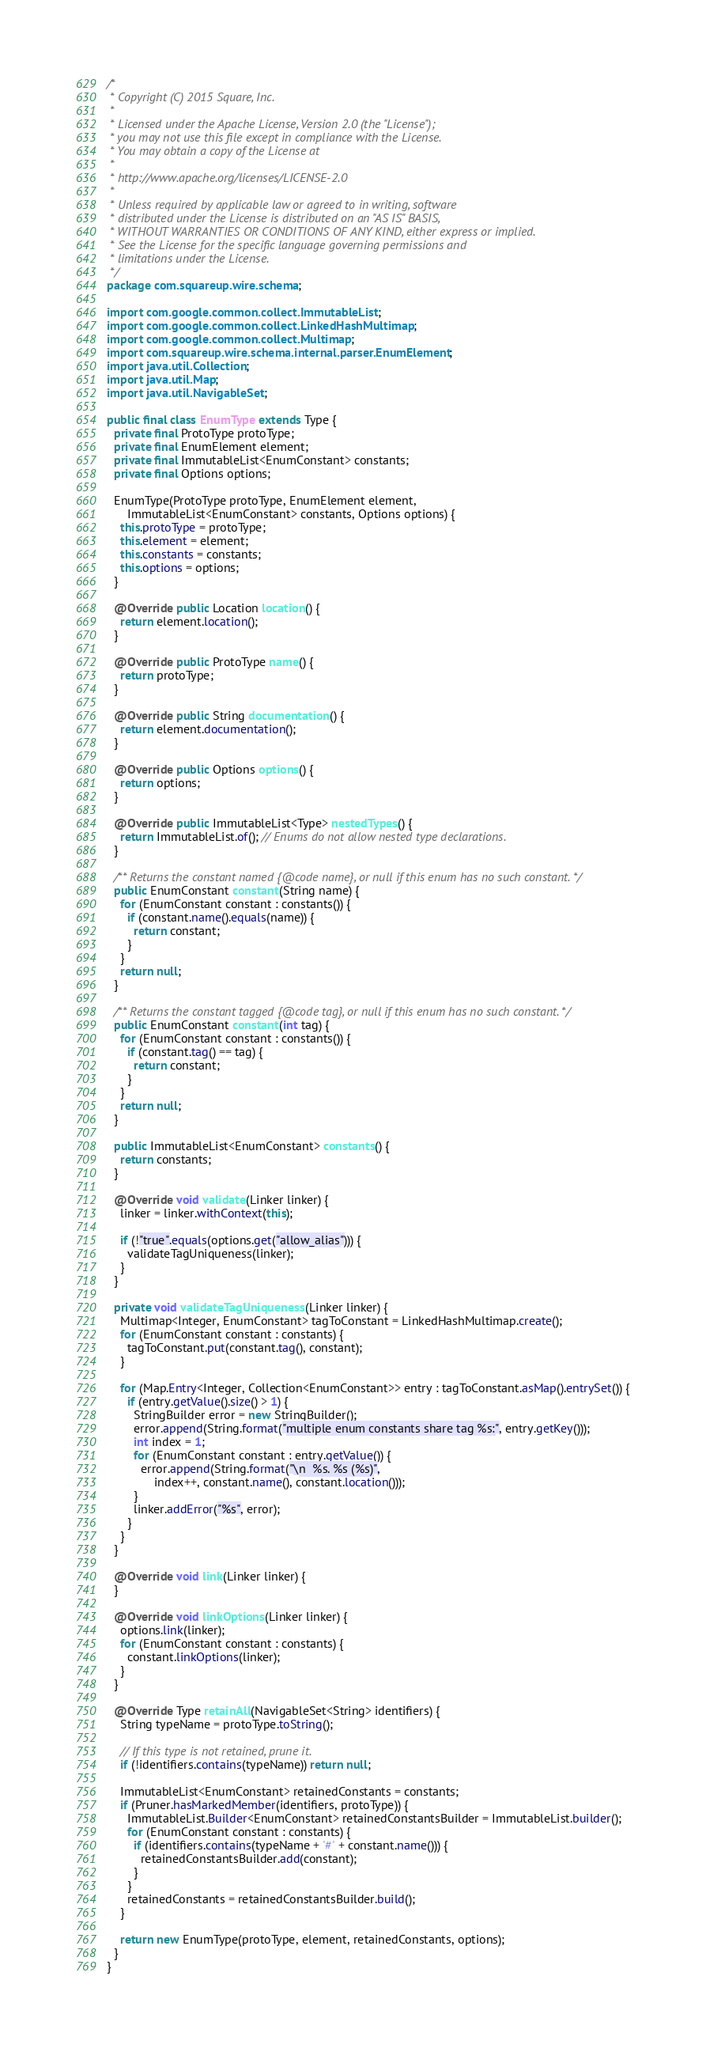<code> <loc_0><loc_0><loc_500><loc_500><_Java_>/*
 * Copyright (C) 2015 Square, Inc.
 *
 * Licensed under the Apache License, Version 2.0 (the "License");
 * you may not use this file except in compliance with the License.
 * You may obtain a copy of the License at
 *
 * http://www.apache.org/licenses/LICENSE-2.0
 *
 * Unless required by applicable law or agreed to in writing, software
 * distributed under the License is distributed on an "AS IS" BASIS,
 * WITHOUT WARRANTIES OR CONDITIONS OF ANY KIND, either express or implied.
 * See the License for the specific language governing permissions and
 * limitations under the License.
 */
package com.squareup.wire.schema;

import com.google.common.collect.ImmutableList;
import com.google.common.collect.LinkedHashMultimap;
import com.google.common.collect.Multimap;
import com.squareup.wire.schema.internal.parser.EnumElement;
import java.util.Collection;
import java.util.Map;
import java.util.NavigableSet;

public final class EnumType extends Type {
  private final ProtoType protoType;
  private final EnumElement element;
  private final ImmutableList<EnumConstant> constants;
  private final Options options;

  EnumType(ProtoType protoType, EnumElement element,
      ImmutableList<EnumConstant> constants, Options options) {
    this.protoType = protoType;
    this.element = element;
    this.constants = constants;
    this.options = options;
  }

  @Override public Location location() {
    return element.location();
  }

  @Override public ProtoType name() {
    return protoType;
  }

  @Override public String documentation() {
    return element.documentation();
  }

  @Override public Options options() {
    return options;
  }

  @Override public ImmutableList<Type> nestedTypes() {
    return ImmutableList.of(); // Enums do not allow nested type declarations.
  }

  /** Returns the constant named {@code name}, or null if this enum has no such constant. */
  public EnumConstant constant(String name) {
    for (EnumConstant constant : constants()) {
      if (constant.name().equals(name)) {
        return constant;
      }
    }
    return null;
  }

  /** Returns the constant tagged {@code tag}, or null if this enum has no such constant. */
  public EnumConstant constant(int tag) {
    for (EnumConstant constant : constants()) {
      if (constant.tag() == tag) {
        return constant;
      }
    }
    return null;
  }

  public ImmutableList<EnumConstant> constants() {
    return constants;
  }

  @Override void validate(Linker linker) {
    linker = linker.withContext(this);

    if (!"true".equals(options.get("allow_alias"))) {
      validateTagUniqueness(linker);
    }
  }

  private void validateTagUniqueness(Linker linker) {
    Multimap<Integer, EnumConstant> tagToConstant = LinkedHashMultimap.create();
    for (EnumConstant constant : constants) {
      tagToConstant.put(constant.tag(), constant);
    }

    for (Map.Entry<Integer, Collection<EnumConstant>> entry : tagToConstant.asMap().entrySet()) {
      if (entry.getValue().size() > 1) {
        StringBuilder error = new StringBuilder();
        error.append(String.format("multiple enum constants share tag %s:", entry.getKey()));
        int index = 1;
        for (EnumConstant constant : entry.getValue()) {
          error.append(String.format("\n  %s. %s (%s)",
              index++, constant.name(), constant.location()));
        }
        linker.addError("%s", error);
      }
    }
  }

  @Override void link(Linker linker) {
  }

  @Override void linkOptions(Linker linker) {
    options.link(linker);
    for (EnumConstant constant : constants) {
      constant.linkOptions(linker);
    }
  }

  @Override Type retainAll(NavigableSet<String> identifiers) {
    String typeName = protoType.toString();

    // If this type is not retained, prune it.
    if (!identifiers.contains(typeName)) return null;

    ImmutableList<EnumConstant> retainedConstants = constants;
    if (Pruner.hasMarkedMember(identifiers, protoType)) {
      ImmutableList.Builder<EnumConstant> retainedConstantsBuilder = ImmutableList.builder();
      for (EnumConstant constant : constants) {
        if (identifiers.contains(typeName + '#' + constant.name())) {
          retainedConstantsBuilder.add(constant);
        }
      }
      retainedConstants = retainedConstantsBuilder.build();
    }

    return new EnumType(protoType, element, retainedConstants, options);
  }
}
</code> 